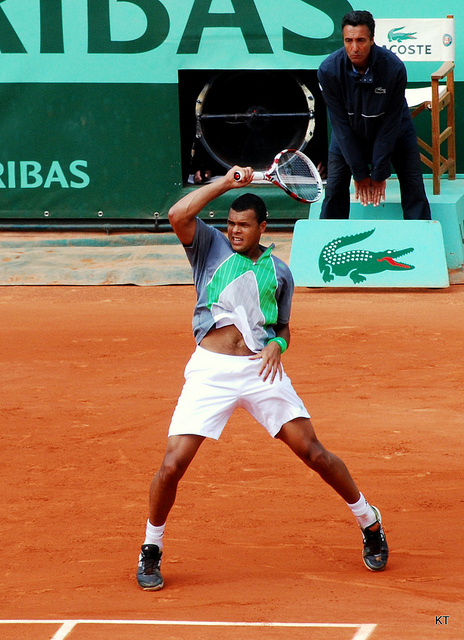Write a detailed description of the given image. The image captures an action-filled moment of a tennis player on a clay court, likely in the middle of a match. The athlete is in motion, focused on playing a backhand stroke with intense concentration. He is dressed in sportswear suitable for a tennis match, consisting of a white shirt with green details, white shorts, and dark tennis shoes. In the background, we can see the umpire sitting in a high chair, observing the play, alongside official tournament signage that includes sponsor logos. 